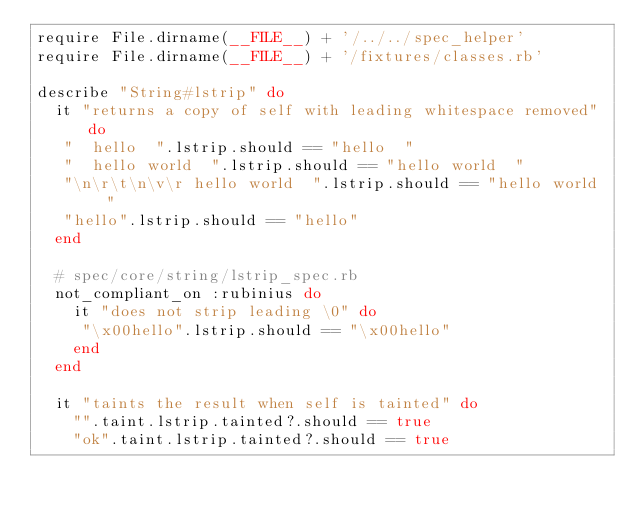Convert code to text. <code><loc_0><loc_0><loc_500><loc_500><_Ruby_>require File.dirname(__FILE__) + '/../../spec_helper'
require File.dirname(__FILE__) + '/fixtures/classes.rb'

describe "String#lstrip" do
  it "returns a copy of self with leading whitespace removed" do
   "  hello  ".lstrip.should == "hello  "
   "  hello world  ".lstrip.should == "hello world  "
   "\n\r\t\n\v\r hello world  ".lstrip.should == "hello world  "
   "hello".lstrip.should == "hello"
  end

  # spec/core/string/lstrip_spec.rb
  not_compliant_on :rubinius do
    it "does not strip leading \0" do
     "\x00hello".lstrip.should == "\x00hello"
    end
  end
  
  it "taints the result when self is tainted" do
    "".taint.lstrip.tainted?.should == true
    "ok".taint.lstrip.tainted?.should == true</code> 